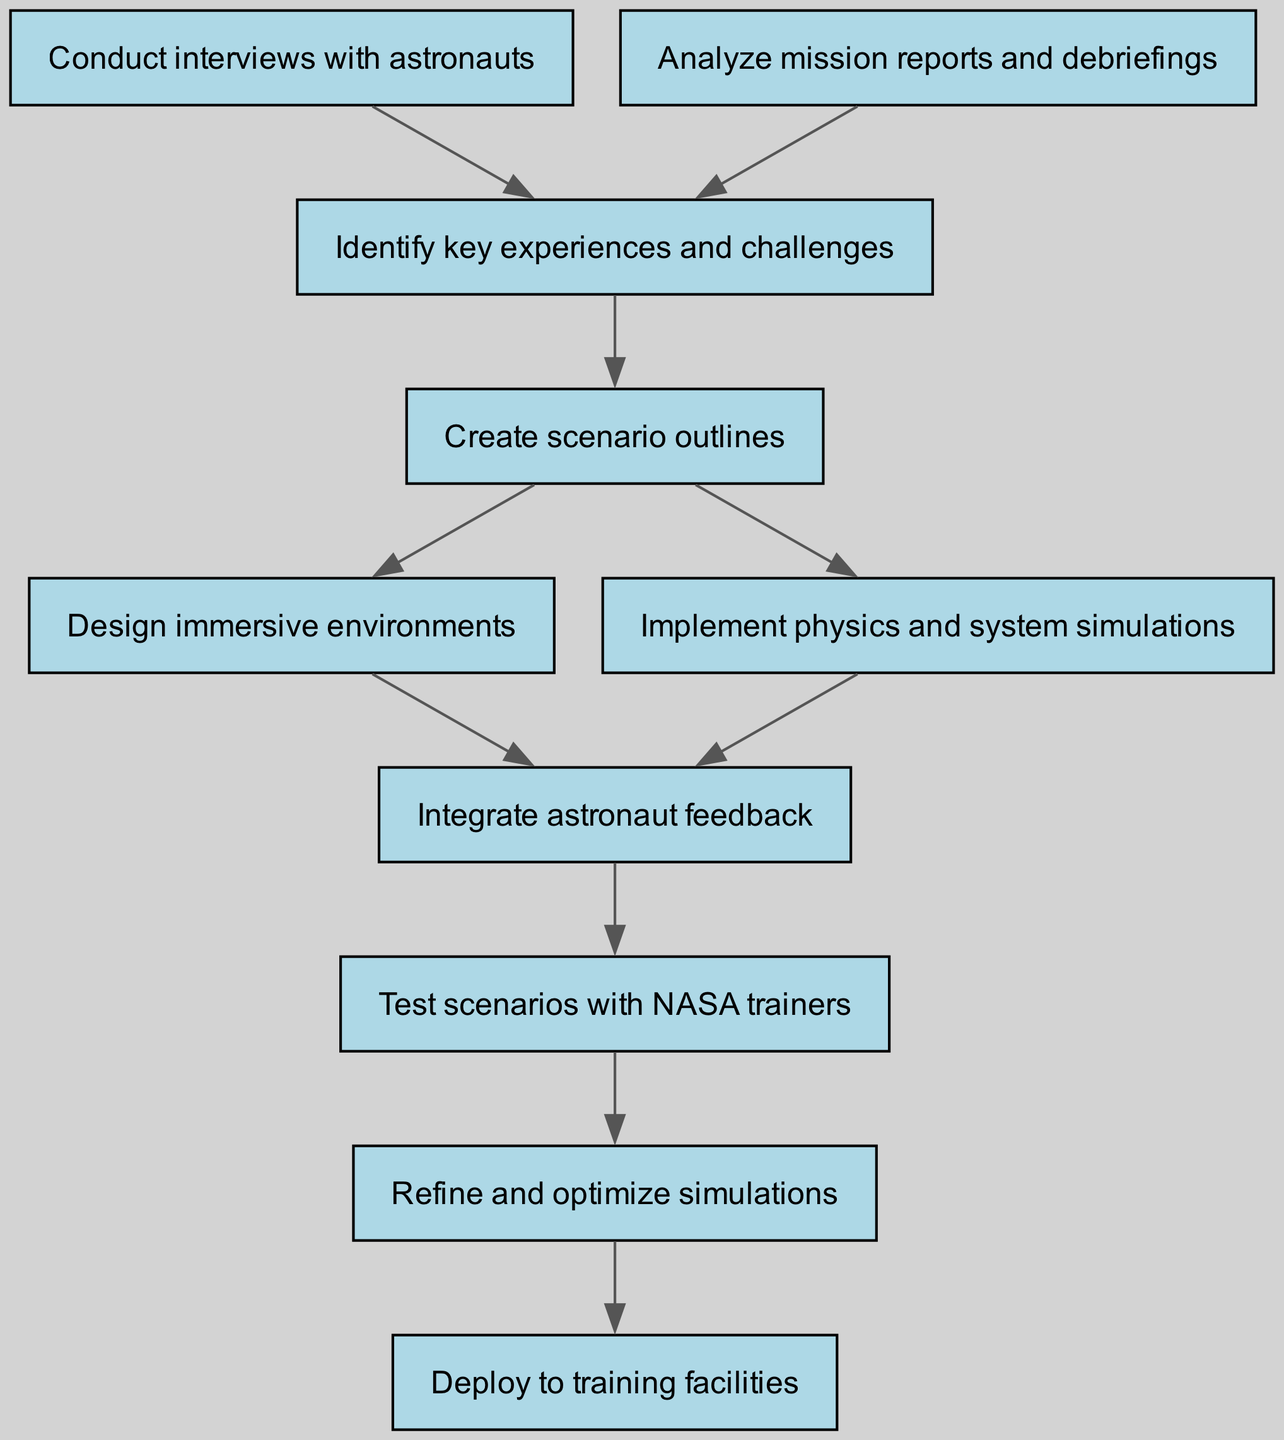What is the first step in the workflow? The diagram starts with the node labeled "Conduct interviews with astronauts", which is the first step in this workflow.
Answer: Conduct interviews with astronauts How many total nodes are there in the diagram? Counting all elements in the diagram, there are ten nodes listed, which represent different steps in the workflow.
Answer: 10 What node follows "Analyze mission reports and debriefings"? From the connections in the diagram, "Analyze mission reports and debriefings" points to "Identify key experiences and challenges" as the next step in the workflow.
Answer: Identify key experiences and challenges What happens after "Integrate astronaut feedback"? The arrow from "Integrate astronaut feedback" leads directly to the node "Test scenarios with NASA trainers", indicating this is the next step.
Answer: Test scenarios with NASA trainers How many connections are there between the nodes? There are ten connections defined in the diagram, which show the flow from one node to another in the workflow.
Answer: 10 What is the outcome after "Refine and optimize simulations"? The final step after "Refine and optimize simulations" is indicated to be "Deploy to training facilities".
Answer: Deploy to training facilities Which nodes lead into "Create scenario outlines"? The incoming connections to "Create scenario outlines" come from "Identify key experiences and challenges" as well as "Conduct interviews with astronauts".
Answer: Conduct interviews with astronauts, Analyze mission reports and debriefings What type of diagram is this? The diagram is a flow chart, which visually represents a sequence of steps and decisions in a workflow.
Answer: Flow chart What is the purpose of the "Design immersive environments" node? It serves as a part of the workflow to create relevant environments based on previous scenario outlines. Directly preceding it, "Create scenario outlines" provides the necessary context for its design.
Answer: To create relevant environments 